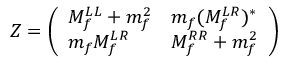<formula> <loc_0><loc_0><loc_500><loc_500>Z = \left ( \begin{array} { l l } { { M _ { f } ^ { L L } + m _ { f } ^ { 2 } } } & { { m _ { f } ( M _ { f } ^ { L R } ) ^ { * } } } \\ { { m _ { f } M _ { f } ^ { L R } } } & { { M _ { f } ^ { R R } + m _ { f } ^ { 2 } } } \end{array} \right )</formula> 